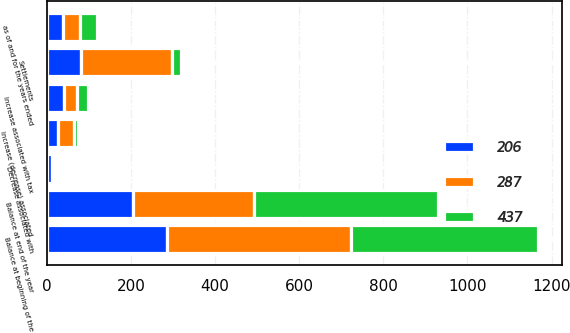<chart> <loc_0><loc_0><loc_500><loc_500><stacked_bar_chart><ecel><fcel>as of and for the years ended<fcel>Balance at beginning of the<fcel>Increase associated with tax<fcel>Increase (decrease) associated<fcel>Settlements<fcel>Decrease associated with<fcel>Balance at end of the year<nl><fcel>206<fcel>39.5<fcel>287<fcel>41<fcel>27<fcel>82<fcel>13<fcel>206<nl><fcel>287<fcel>39.5<fcel>437<fcel>31<fcel>38<fcel>216<fcel>3<fcel>287<nl><fcel>437<fcel>39.5<fcel>443<fcel>25<fcel>9<fcel>21<fcel>1<fcel>437<nl></chart> 